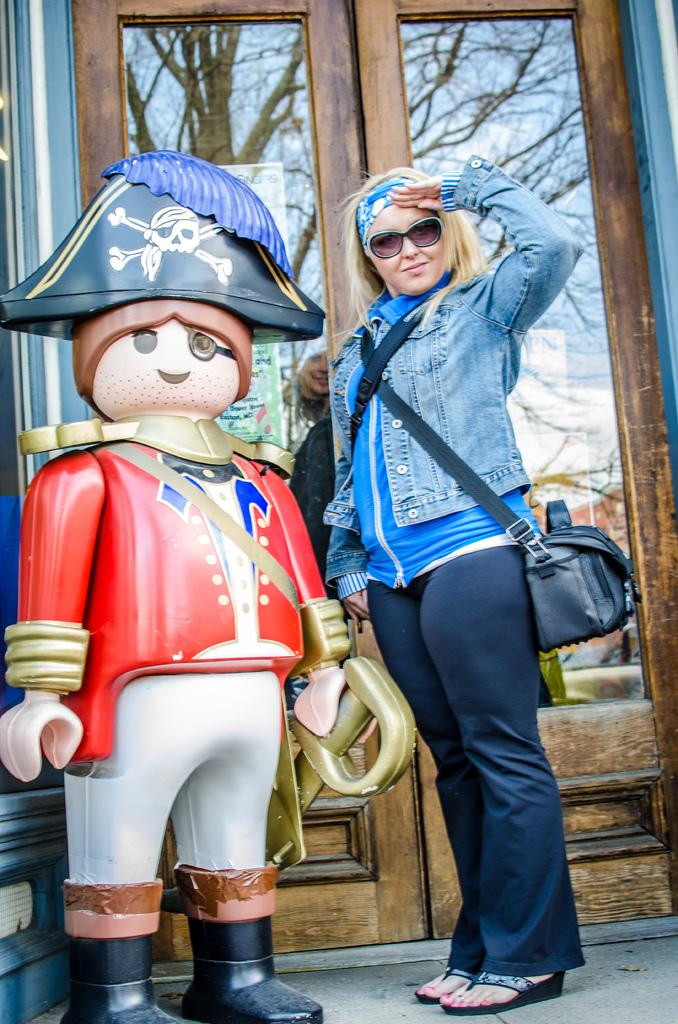Who is the main subject in the image? There is a woman standing in the middle of the image. What is the woman doing in the image? The woman is smiling. What object is beside the woman? There is a doll beside the woman. What can be seen in the background of the image? There is a door visible in the background. What type of fiction is the woman reading in the image? There is no book or any form of reading material present in the image, so it cannot be determined if the woman is reading fiction or any other type of content. 